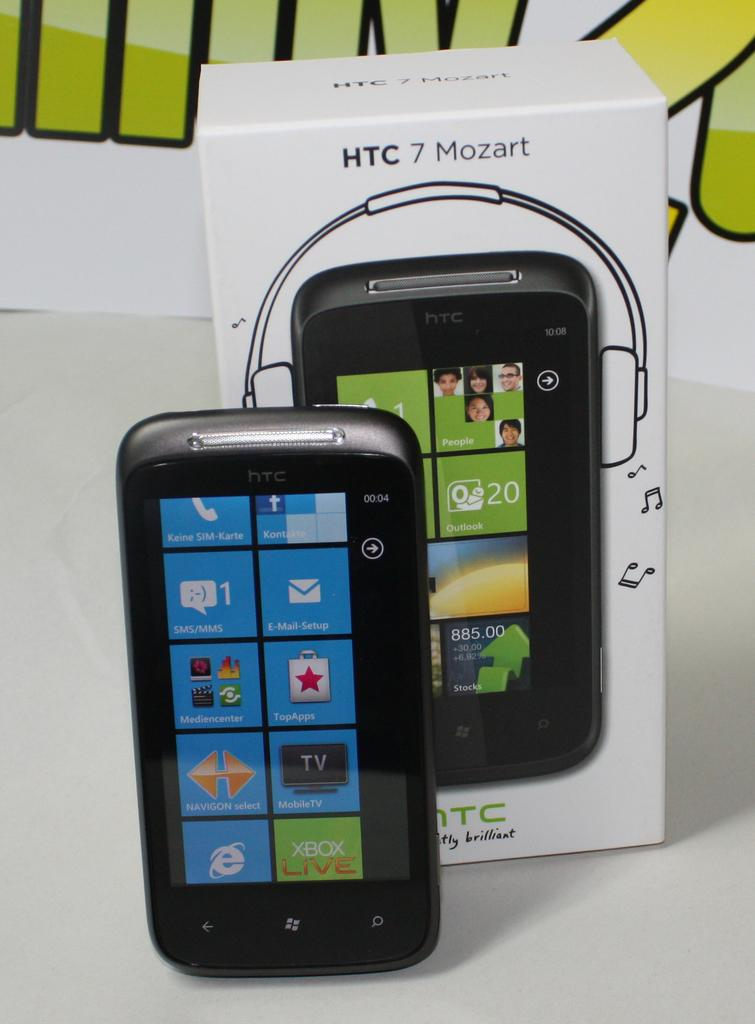<image>
Render a clear and concise summary of the photo. A new HTC MP3 player still including the box it came in. 